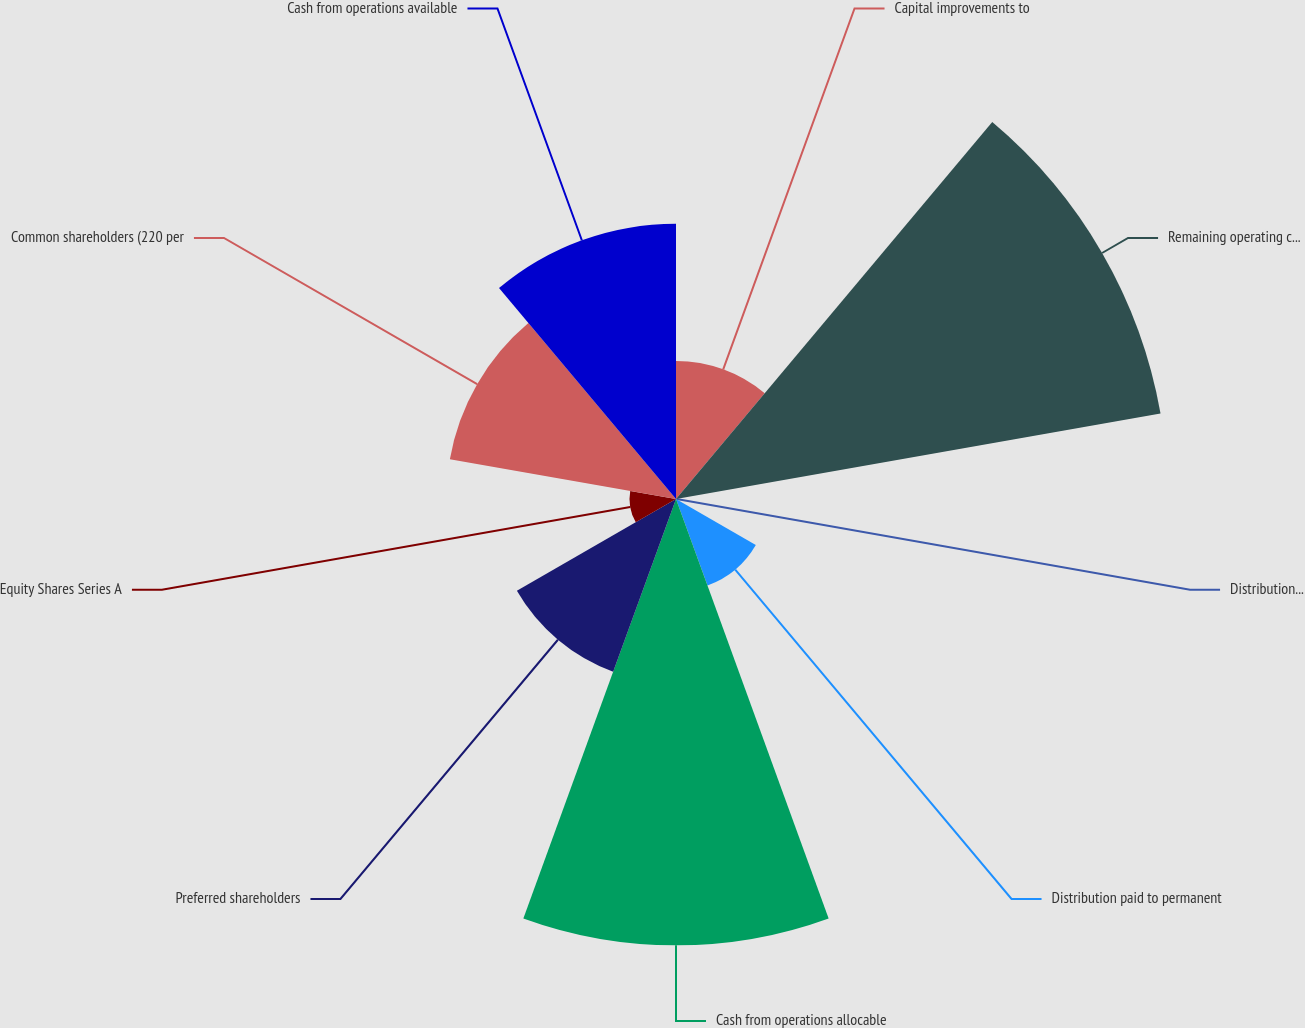<chart> <loc_0><loc_0><loc_500><loc_500><pie_chart><fcel>Capital improvements to<fcel>Remaining operating cash flow<fcel>Distributions paid to<fcel>Distribution paid to permanent<fcel>Cash from operations allocable<fcel>Preferred shareholders<fcel>Equity Shares Series A<fcel>Common shareholders (220 per<fcel>Cash from operations available<nl><fcel>7.25%<fcel>25.84%<fcel>0.03%<fcel>4.84%<fcel>23.44%<fcel>9.65%<fcel>2.44%<fcel>12.06%<fcel>14.46%<nl></chart> 